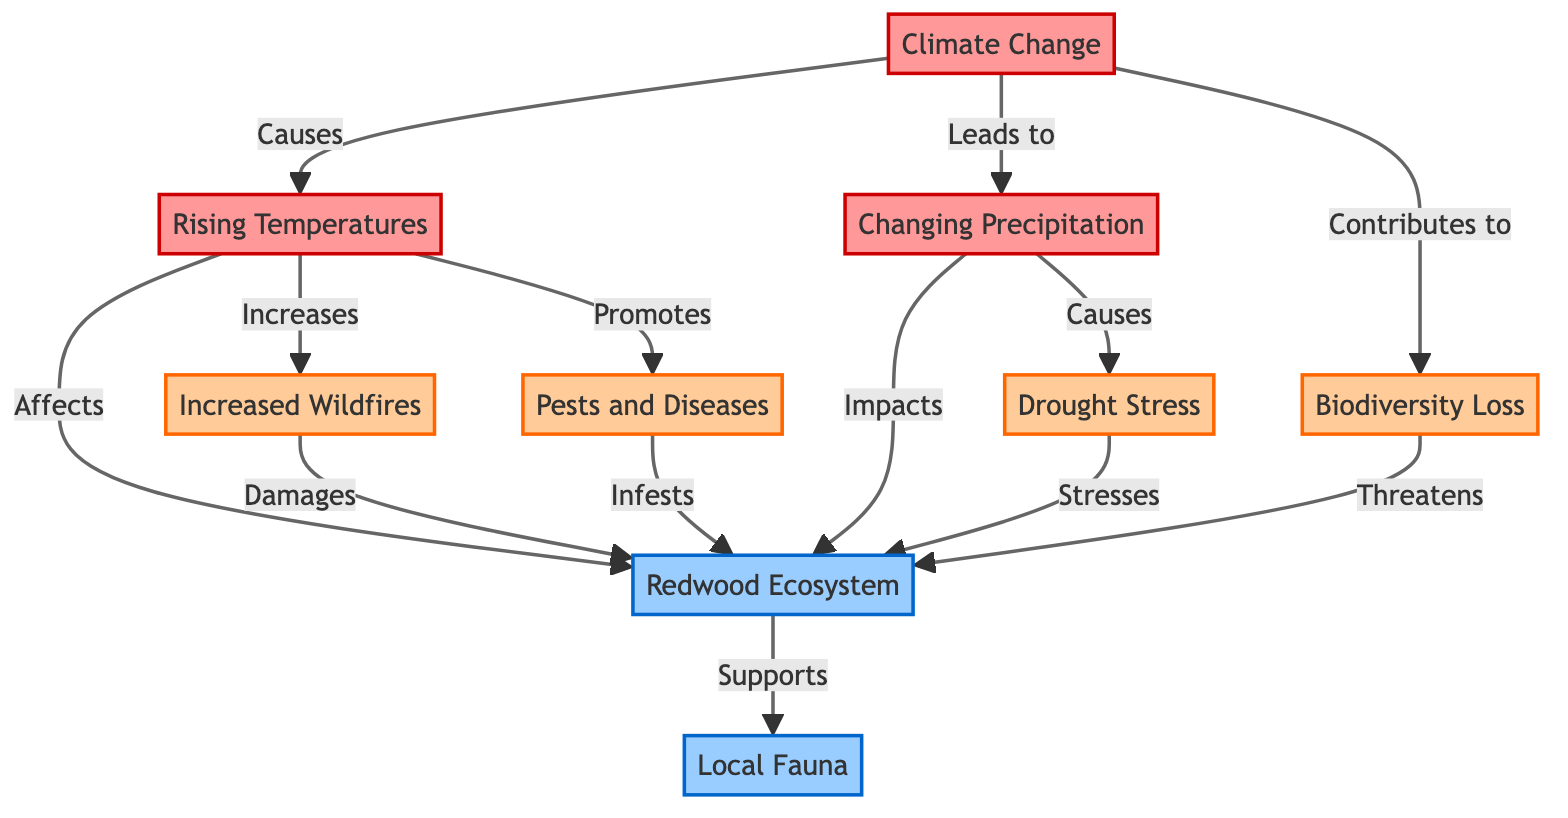What causes rising temperatures? The diagram indicates that rising temperatures are a result of climate change. This is evidenced by the flow from the "Climate Change" node to the "Rising Temperatures" node.
Answer: Climate Change What directly impacts the redwood ecosystem? The diagram illustrates two factors that directly impact the redwood ecosystem: rising temperatures and changing precipitation. Both have arrows pointing towards the "Redwood Ecosystem" node.
Answer: Rising Temperatures, Changing Precipitation How many environmental stressors are shown in the diagram? The diagram lists four environmental stressors impacting the redwood ecosystem: increased wildfires, drought stress, pests and diseases, and biodiversity loss. By counting these nodes reveals the total number of stressors.
Answer: 4 Which factor promotes pests and diseases? The relationship shown in the diagram indicates that rising temperatures promote pests and diseases, as an arrow flows from the "Rising Temperatures" node to the "Pests and Diseases" node.
Answer: Rising Temperatures What is the effect of drought on the redwood ecosystem? According to the diagram, drought stresses the redwood ecosystem. This relationship is depicted by the arrow flowing from the "Drought" node to the "Redwood Ecosystem" node.
Answer: Stresses How does climate change contribute to biodiversity loss? The diagram demonstrates a direct contribution of climate change to biodiversity loss. This is shown when arrows point from "Climate Change" to "Biodiversity Loss," implying a connection between the two.
Answer: Contributes to What negatively affects local fauna? The diagram indicates that biodiversity loss threatens local fauna. The relationship is illustrated by the flow from "Biodiversity Loss" to "Local Fauna," showcasing that it has a negative impact.
Answer: Threatens What are two ways increased wildfires impact the redwood ecosystem? The diagram shows that increased wildfires damage the redwood ecosystem. By analyzing the flow from "Increased Wildfires" to "Redwood Ecosystem," we see a direct negative impact listed.
Answer: Damages How many nodes are linked to the redwood ecosystem? By examining the diagram, the redwood ecosystem node connects with five other nodes: rising temperatures, changing precipitation, drought, increased wildfires, and pests and diseases. Thus, the count of linked nodes can be totaled.
Answer: 5 